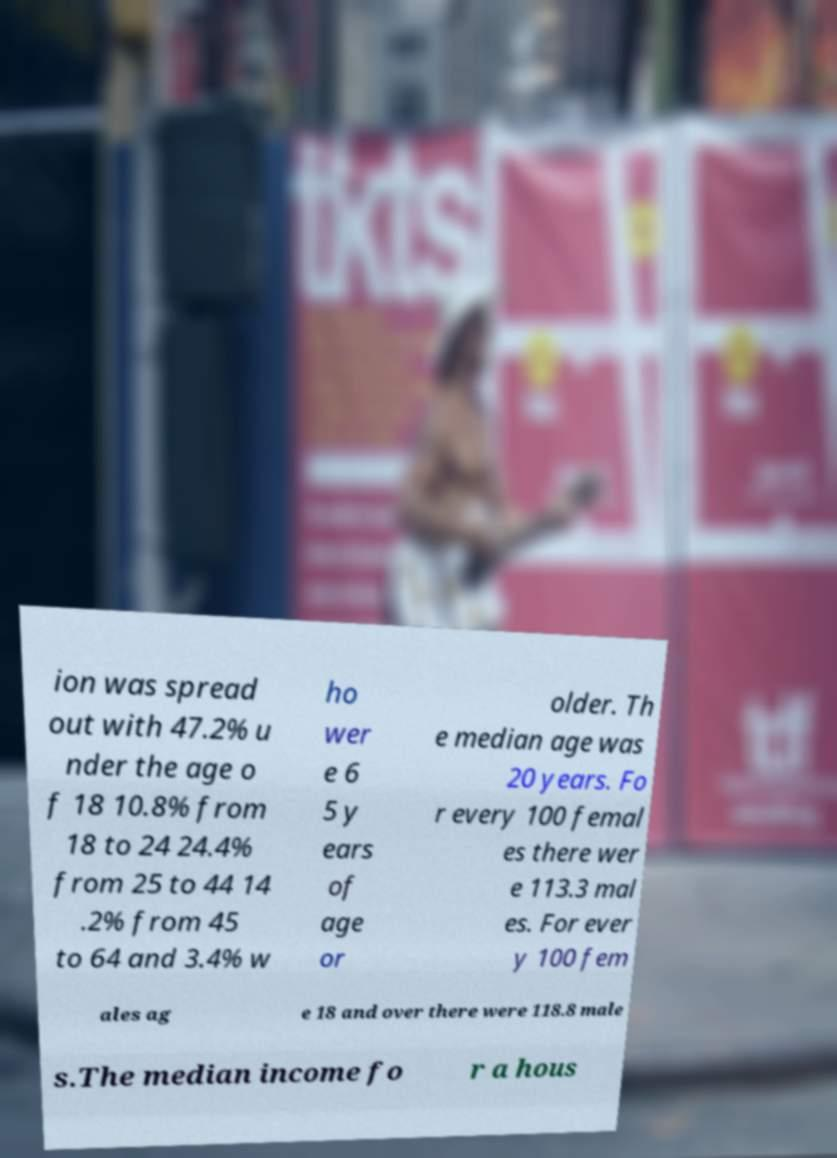Please read and relay the text visible in this image. What does it say? ion was spread out with 47.2% u nder the age o f 18 10.8% from 18 to 24 24.4% from 25 to 44 14 .2% from 45 to 64 and 3.4% w ho wer e 6 5 y ears of age or older. Th e median age was 20 years. Fo r every 100 femal es there wer e 113.3 mal es. For ever y 100 fem ales ag e 18 and over there were 118.8 male s.The median income fo r a hous 